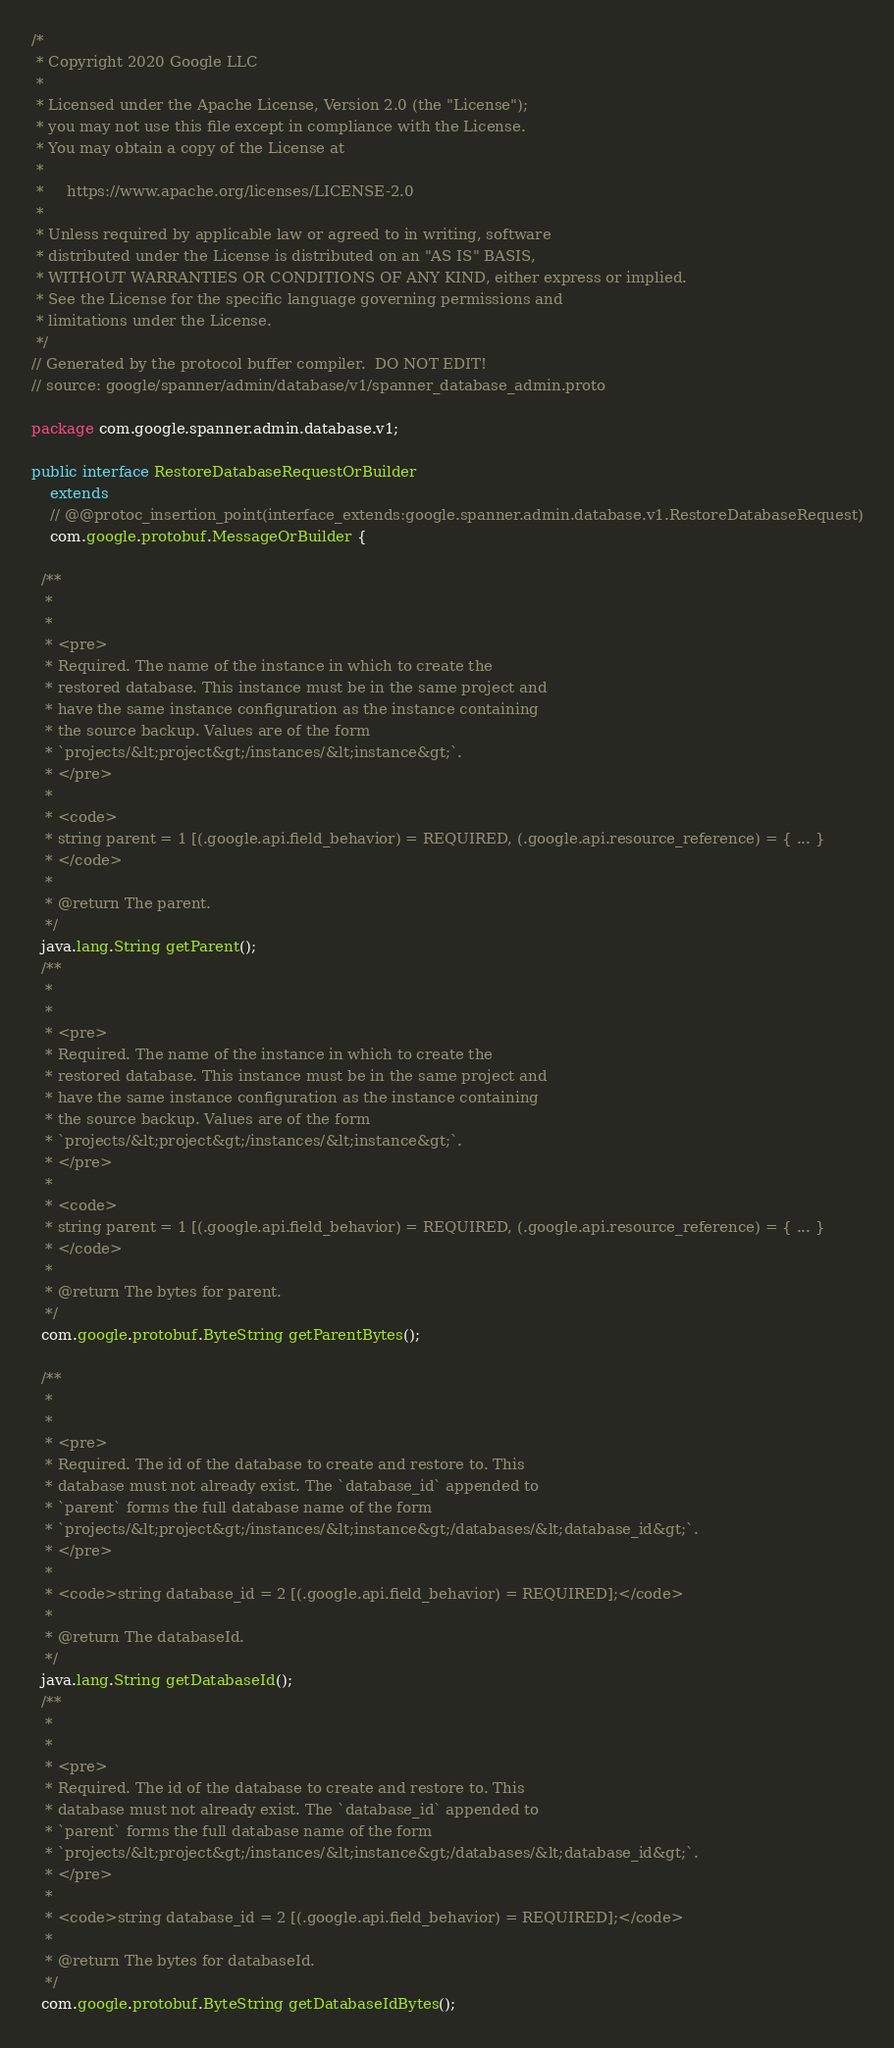Convert code to text. <code><loc_0><loc_0><loc_500><loc_500><_Java_>/*
 * Copyright 2020 Google LLC
 *
 * Licensed under the Apache License, Version 2.0 (the "License");
 * you may not use this file except in compliance with the License.
 * You may obtain a copy of the License at
 *
 *     https://www.apache.org/licenses/LICENSE-2.0
 *
 * Unless required by applicable law or agreed to in writing, software
 * distributed under the License is distributed on an "AS IS" BASIS,
 * WITHOUT WARRANTIES OR CONDITIONS OF ANY KIND, either express or implied.
 * See the License for the specific language governing permissions and
 * limitations under the License.
 */
// Generated by the protocol buffer compiler.  DO NOT EDIT!
// source: google/spanner/admin/database/v1/spanner_database_admin.proto

package com.google.spanner.admin.database.v1;

public interface RestoreDatabaseRequestOrBuilder
    extends
    // @@protoc_insertion_point(interface_extends:google.spanner.admin.database.v1.RestoreDatabaseRequest)
    com.google.protobuf.MessageOrBuilder {

  /**
   *
   *
   * <pre>
   * Required. The name of the instance in which to create the
   * restored database. This instance must be in the same project and
   * have the same instance configuration as the instance containing
   * the source backup. Values are of the form
   * `projects/&lt;project&gt;/instances/&lt;instance&gt;`.
   * </pre>
   *
   * <code>
   * string parent = 1 [(.google.api.field_behavior) = REQUIRED, (.google.api.resource_reference) = { ... }
   * </code>
   *
   * @return The parent.
   */
  java.lang.String getParent();
  /**
   *
   *
   * <pre>
   * Required. The name of the instance in which to create the
   * restored database. This instance must be in the same project and
   * have the same instance configuration as the instance containing
   * the source backup. Values are of the form
   * `projects/&lt;project&gt;/instances/&lt;instance&gt;`.
   * </pre>
   *
   * <code>
   * string parent = 1 [(.google.api.field_behavior) = REQUIRED, (.google.api.resource_reference) = { ... }
   * </code>
   *
   * @return The bytes for parent.
   */
  com.google.protobuf.ByteString getParentBytes();

  /**
   *
   *
   * <pre>
   * Required. The id of the database to create and restore to. This
   * database must not already exist. The `database_id` appended to
   * `parent` forms the full database name of the form
   * `projects/&lt;project&gt;/instances/&lt;instance&gt;/databases/&lt;database_id&gt;`.
   * </pre>
   *
   * <code>string database_id = 2 [(.google.api.field_behavior) = REQUIRED];</code>
   *
   * @return The databaseId.
   */
  java.lang.String getDatabaseId();
  /**
   *
   *
   * <pre>
   * Required. The id of the database to create and restore to. This
   * database must not already exist. The `database_id` appended to
   * `parent` forms the full database name of the form
   * `projects/&lt;project&gt;/instances/&lt;instance&gt;/databases/&lt;database_id&gt;`.
   * </pre>
   *
   * <code>string database_id = 2 [(.google.api.field_behavior) = REQUIRED];</code>
   *
   * @return The bytes for databaseId.
   */
  com.google.protobuf.ByteString getDatabaseIdBytes();
</code> 